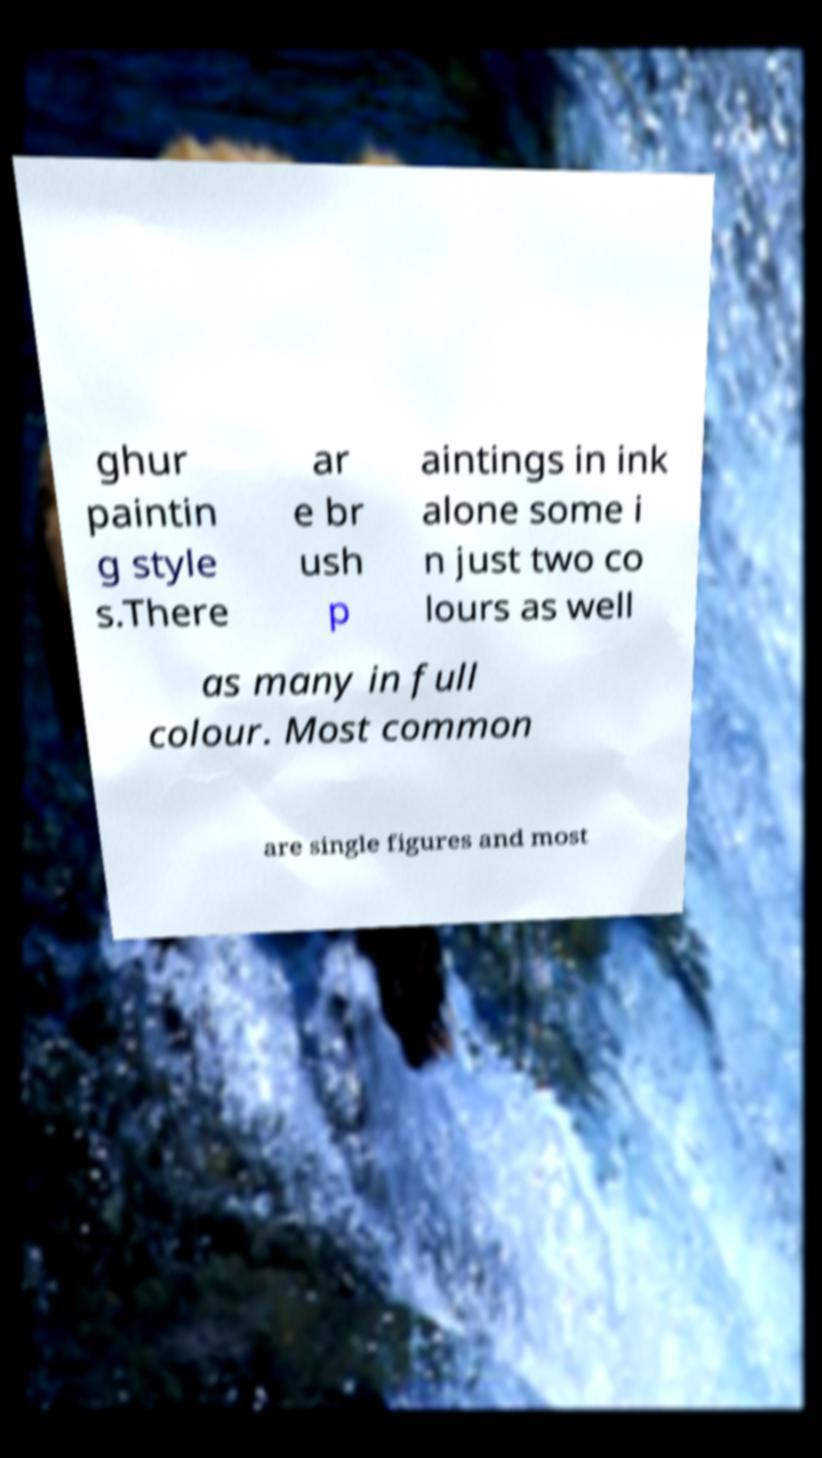Can you accurately transcribe the text from the provided image for me? ghur paintin g style s.There ar e br ush p aintings in ink alone some i n just two co lours as well as many in full colour. Most common are single figures and most 